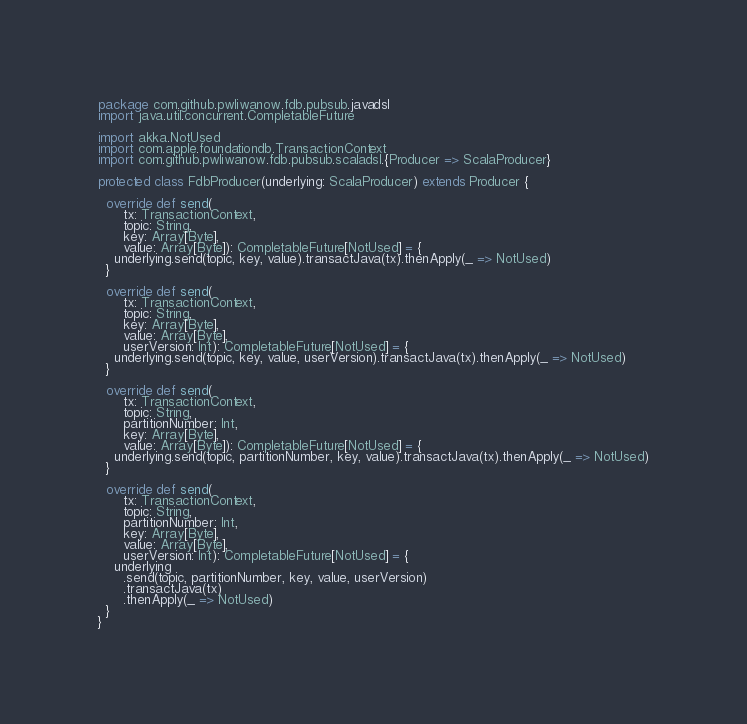<code> <loc_0><loc_0><loc_500><loc_500><_Scala_>package com.github.pwliwanow.fdb.pubsub.javadsl
import java.util.concurrent.CompletableFuture

import akka.NotUsed
import com.apple.foundationdb.TransactionContext
import com.github.pwliwanow.fdb.pubsub.scaladsl.{Producer => ScalaProducer}

protected class FdbProducer(underlying: ScalaProducer) extends Producer {

  override def send(
      tx: TransactionContext,
      topic: String,
      key: Array[Byte],
      value: Array[Byte]): CompletableFuture[NotUsed] = {
    underlying.send(topic, key, value).transactJava(tx).thenApply(_ => NotUsed)
  }

  override def send(
      tx: TransactionContext,
      topic: String,
      key: Array[Byte],
      value: Array[Byte],
      userVersion: Int): CompletableFuture[NotUsed] = {
    underlying.send(topic, key, value, userVersion).transactJava(tx).thenApply(_ => NotUsed)
  }

  override def send(
      tx: TransactionContext,
      topic: String,
      partitionNumber: Int,
      key: Array[Byte],
      value: Array[Byte]): CompletableFuture[NotUsed] = {
    underlying.send(topic, partitionNumber, key, value).transactJava(tx).thenApply(_ => NotUsed)
  }

  override def send(
      tx: TransactionContext,
      topic: String,
      partitionNumber: Int,
      key: Array[Byte],
      value: Array[Byte],
      userVersion: Int): CompletableFuture[NotUsed] = {
    underlying
      .send(topic, partitionNumber, key, value, userVersion)
      .transactJava(tx)
      .thenApply(_ => NotUsed)
  }
}
</code> 